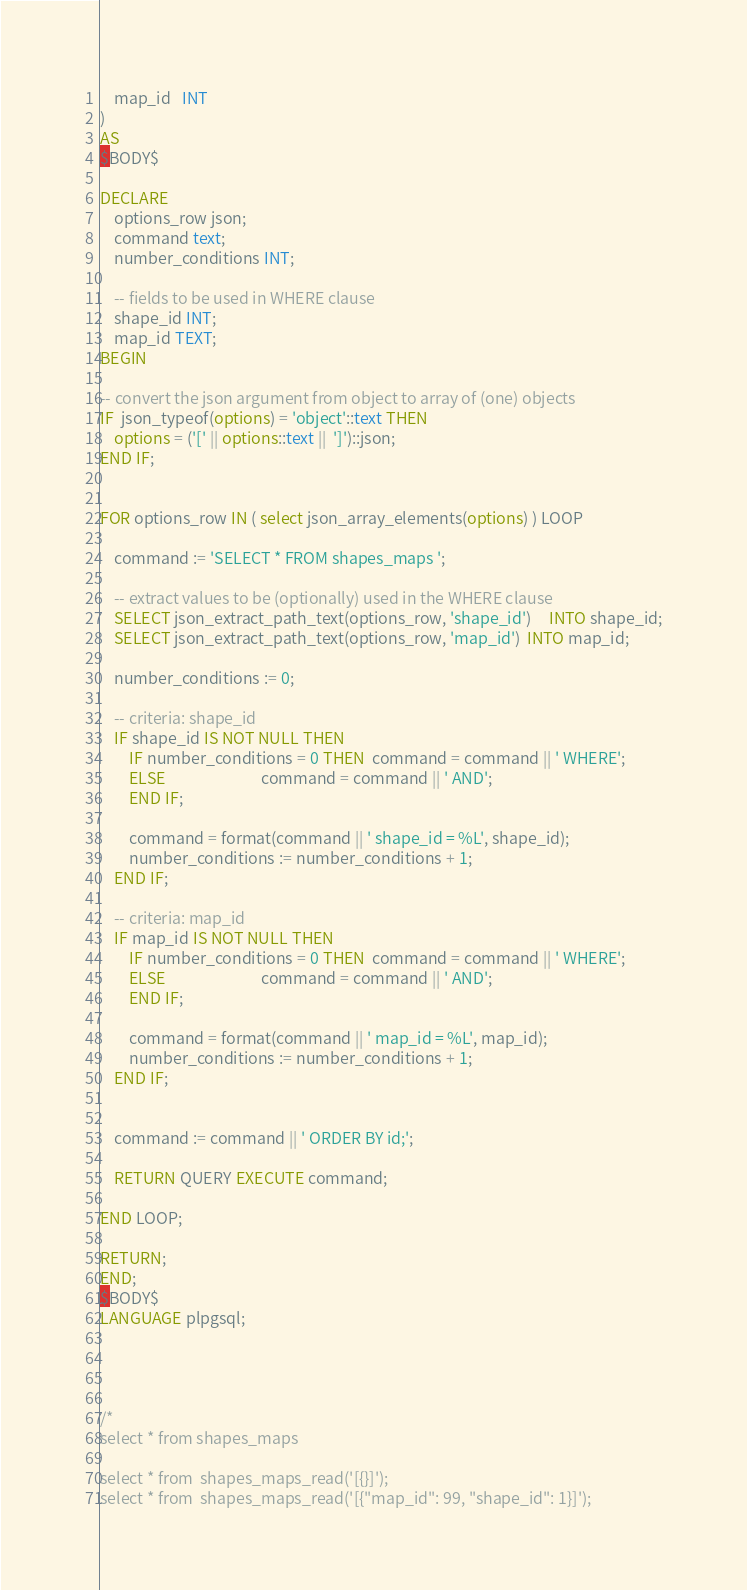<code> <loc_0><loc_0><loc_500><loc_500><_SQL_>	map_id   INT
)
AS
$BODY$

DECLARE
	options_row json;
	command text;
	number_conditions INT;

	-- fields to be used in WHERE clause
	shape_id INT;
	map_id TEXT;
BEGIN

-- convert the json argument from object to array of (one) objects
IF  json_typeof(options) = 'object'::text THEN
	options = ('[' || options::text ||  ']')::json;
END IF;


FOR options_row IN ( select json_array_elements(options) ) LOOP

	command := 'SELECT * FROM shapes_maps ';
			
	-- extract values to be (optionally) used in the WHERE clause
	SELECT json_extract_path_text(options_row, 'shape_id')     INTO shape_id;
	SELECT json_extract_path_text(options_row, 'map_id')  INTO map_id;

	number_conditions := 0;
	
	-- criteria: shape_id
	IF shape_id IS NOT NULL THEN
		IF number_conditions = 0 THEN  command = command || ' WHERE';  
		ELSE                           command = command || ' AND';
		END IF;

		command = format(command || ' shape_id = %L', shape_id);
		number_conditions := number_conditions + 1;
	END IF;

	-- criteria: map_id
	IF map_id IS NOT NULL THEN
		IF number_conditions = 0 THEN  command = command || ' WHERE';  
		ELSE                           command = command || ' AND';
		END IF;

		command = format(command || ' map_id = %L', map_id);
		number_conditions := number_conditions + 1;
	END IF;

	
	command := command || ' ORDER BY id;';

	RETURN QUERY EXECUTE command;

END LOOP;
		
RETURN;
END;
$BODY$
LANGUAGE plpgsql;




/*
select * from shapes_maps

select * from  shapes_maps_read('[{}]');
select * from  shapes_maps_read('[{"map_id": 99, "shape_id": 1}]');</code> 